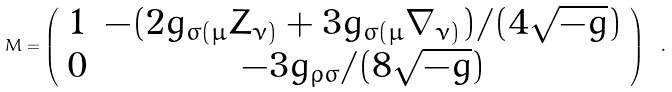Convert formula to latex. <formula><loc_0><loc_0><loc_500><loc_500>M = \left ( \begin{array} { c c } 1 & - ( 2 g _ { \sigma ( \mu } Z _ { \nu ) } + 3 g _ { \sigma ( \mu } \nabla _ { \nu ) } ) / ( 4 \sqrt { - g } ) \\ 0 & - 3 g _ { \rho \sigma } / ( 8 \sqrt { - g } ) \end{array} \right ) \ .</formula> 